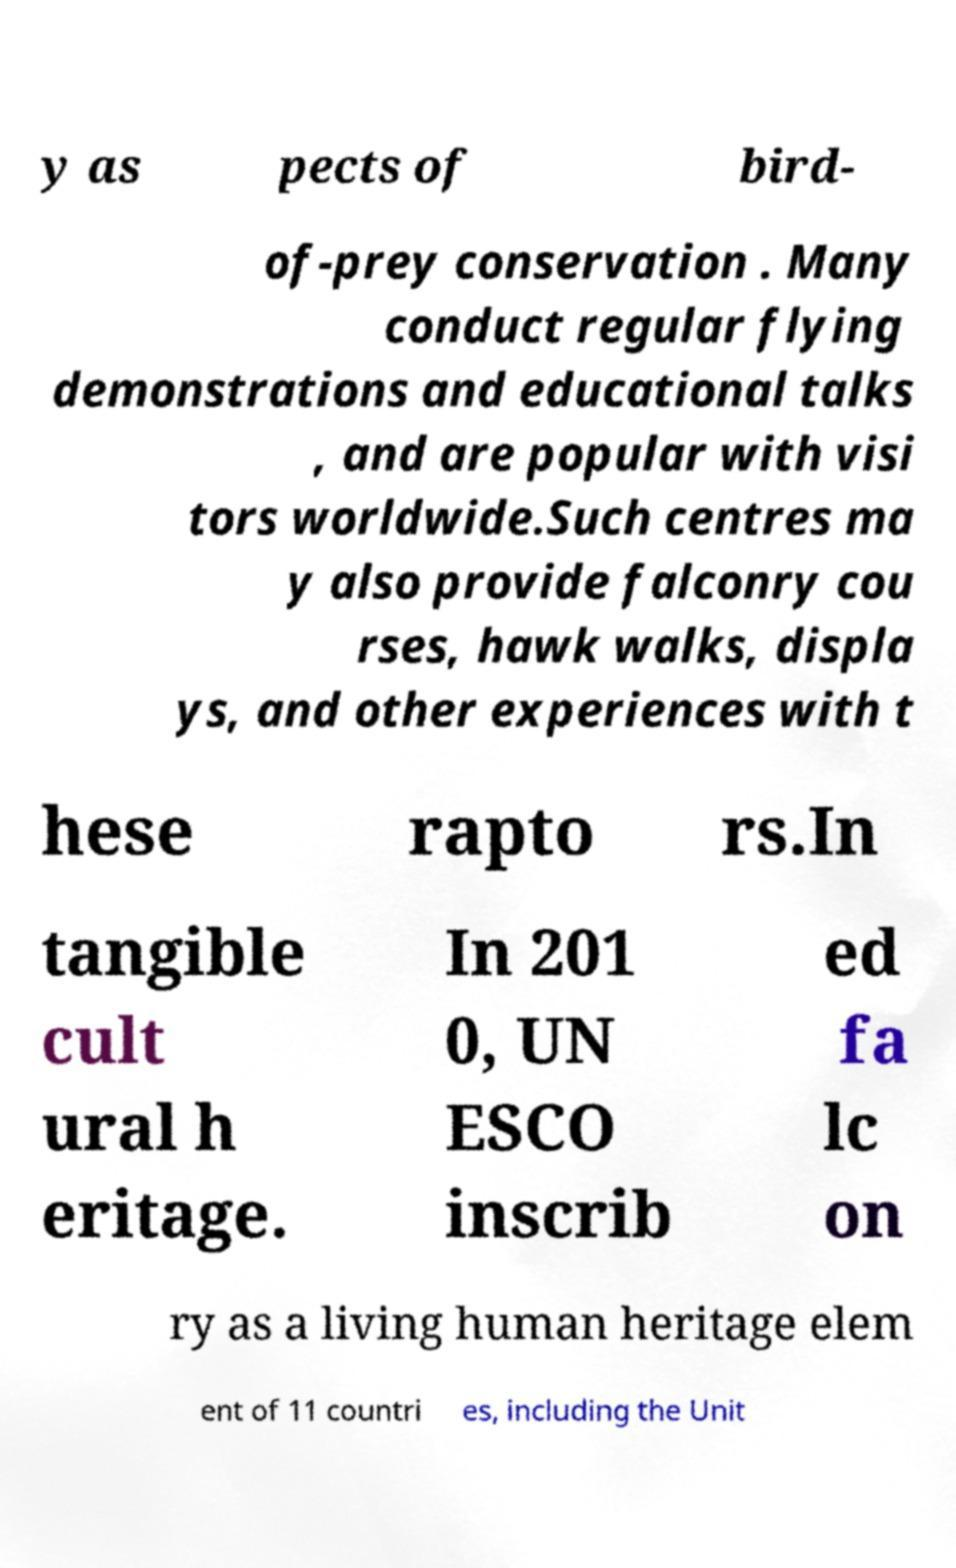Please read and relay the text visible in this image. What does it say? y as pects of bird- of-prey conservation . Many conduct regular flying demonstrations and educational talks , and are popular with visi tors worldwide.Such centres ma y also provide falconry cou rses, hawk walks, displa ys, and other experiences with t hese rapto rs.In tangible cult ural h eritage. In 201 0, UN ESCO inscrib ed fa lc on ry as a living human heritage elem ent of 11 countri es, including the Unit 